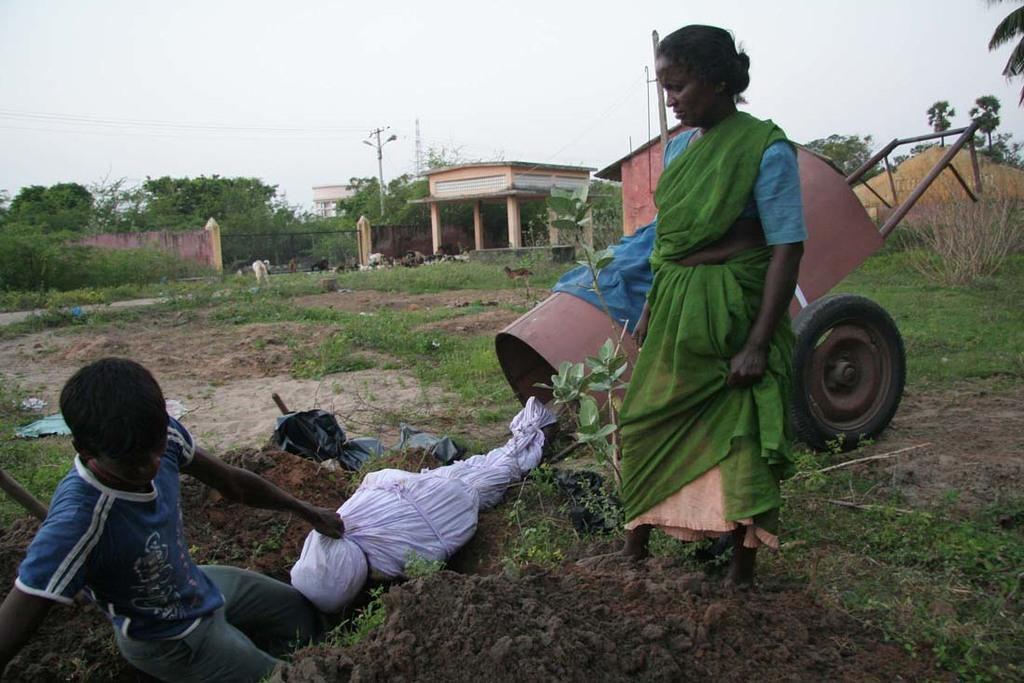Could you give a brief overview of what you see in this image? In this picture we can see there are two people on the path and behind the people there is a cart, gate, wall, trees and electric pole with cables. Behind the trees there is a sky. 